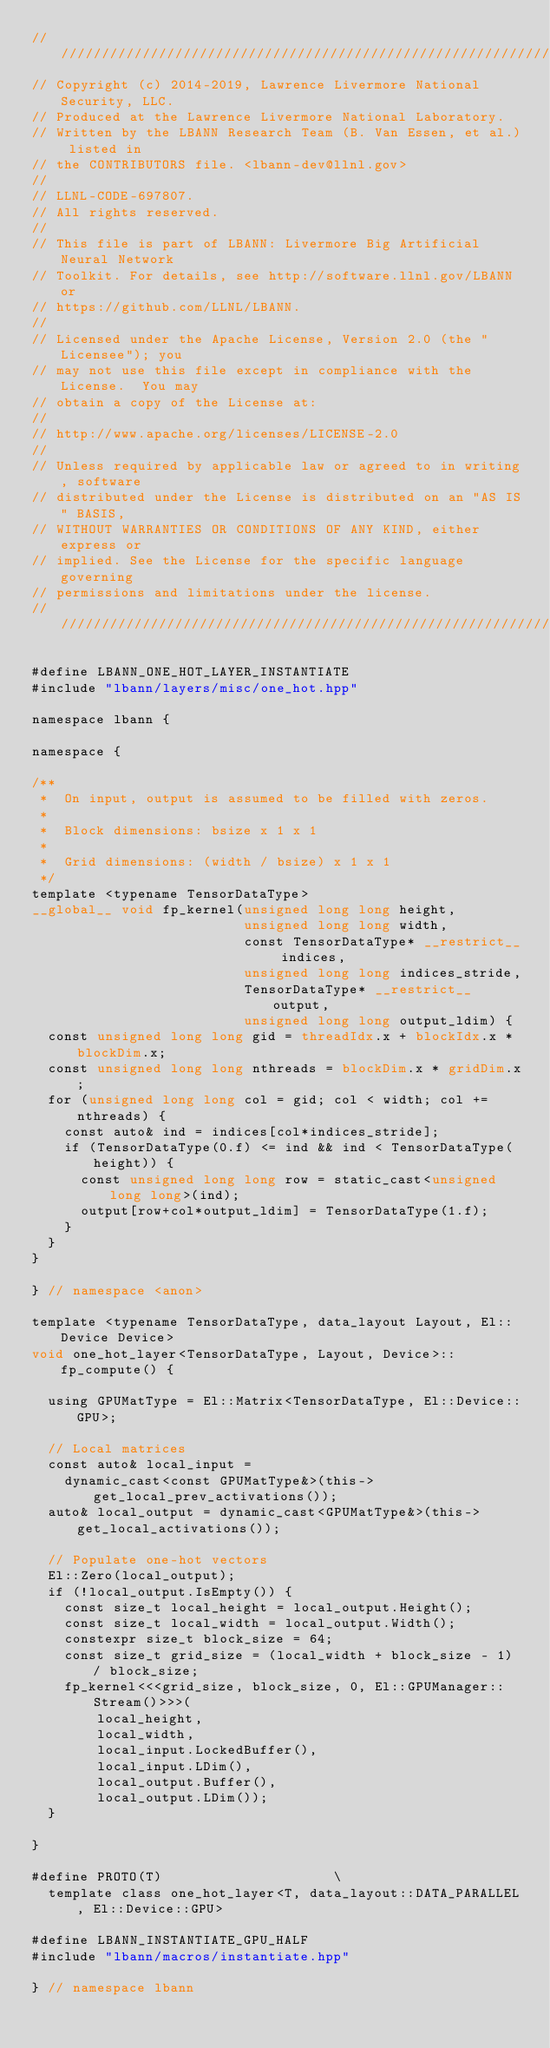Convert code to text. <code><loc_0><loc_0><loc_500><loc_500><_Cuda_>////////////////////////////////////////////////////////////////////////////////
// Copyright (c) 2014-2019, Lawrence Livermore National Security, LLC.
// Produced at the Lawrence Livermore National Laboratory.
// Written by the LBANN Research Team (B. Van Essen, et al.) listed in
// the CONTRIBUTORS file. <lbann-dev@llnl.gov>
//
// LLNL-CODE-697807.
// All rights reserved.
//
// This file is part of LBANN: Livermore Big Artificial Neural Network
// Toolkit. For details, see http://software.llnl.gov/LBANN or
// https://github.com/LLNL/LBANN.
//
// Licensed under the Apache License, Version 2.0 (the "Licensee"); you
// may not use this file except in compliance with the License.  You may
// obtain a copy of the License at:
//
// http://www.apache.org/licenses/LICENSE-2.0
//
// Unless required by applicable law or agreed to in writing, software
// distributed under the License is distributed on an "AS IS" BASIS,
// WITHOUT WARRANTIES OR CONDITIONS OF ANY KIND, either express or
// implied. See the License for the specific language governing
// permissions and limitations under the license.
////////////////////////////////////////////////////////////////////////////////

#define LBANN_ONE_HOT_LAYER_INSTANTIATE
#include "lbann/layers/misc/one_hot.hpp"

namespace lbann {

namespace {

/**
 *  On input, output is assumed to be filled with zeros.
 *
 *  Block dimensions: bsize x 1 x 1
 *
 *  Grid dimensions: (width / bsize) x 1 x 1
 */
template <typename TensorDataType>
__global__ void fp_kernel(unsigned long long height,
                          unsigned long long width,
                          const TensorDataType* __restrict__ indices,
                          unsigned long long indices_stride,
                          TensorDataType* __restrict__ output,
                          unsigned long long output_ldim) {
  const unsigned long long gid = threadIdx.x + blockIdx.x * blockDim.x;
  const unsigned long long nthreads = blockDim.x * gridDim.x;
  for (unsigned long long col = gid; col < width; col += nthreads) {
    const auto& ind = indices[col*indices_stride];
    if (TensorDataType(0.f) <= ind && ind < TensorDataType(height)) {
      const unsigned long long row = static_cast<unsigned long long>(ind);
      output[row+col*output_ldim] = TensorDataType(1.f);
    }
  }
}

} // namespace <anon>

template <typename TensorDataType, data_layout Layout, El::Device Device>
void one_hot_layer<TensorDataType, Layout, Device>::fp_compute() {

  using GPUMatType = El::Matrix<TensorDataType, El::Device::GPU>;

  // Local matrices
  const auto& local_input =
    dynamic_cast<const GPUMatType&>(this->get_local_prev_activations());
  auto& local_output = dynamic_cast<GPUMatType&>(this->get_local_activations());

  // Populate one-hot vectors
  El::Zero(local_output);
  if (!local_output.IsEmpty()) {
    const size_t local_height = local_output.Height();
    const size_t local_width = local_output.Width();
    constexpr size_t block_size = 64;
    const size_t grid_size = (local_width + block_size - 1) / block_size;
    fp_kernel<<<grid_size, block_size, 0, El::GPUManager::Stream()>>>(
        local_height,
        local_width,
        local_input.LockedBuffer(),
        local_input.LDim(),
        local_output.Buffer(),
        local_output.LDim());
  }

}

#define PROTO(T)                     \
  template class one_hot_layer<T, data_layout::DATA_PARALLEL, El::Device::GPU>

#define LBANN_INSTANTIATE_GPU_HALF
#include "lbann/macros/instantiate.hpp"

} // namespace lbann
</code> 